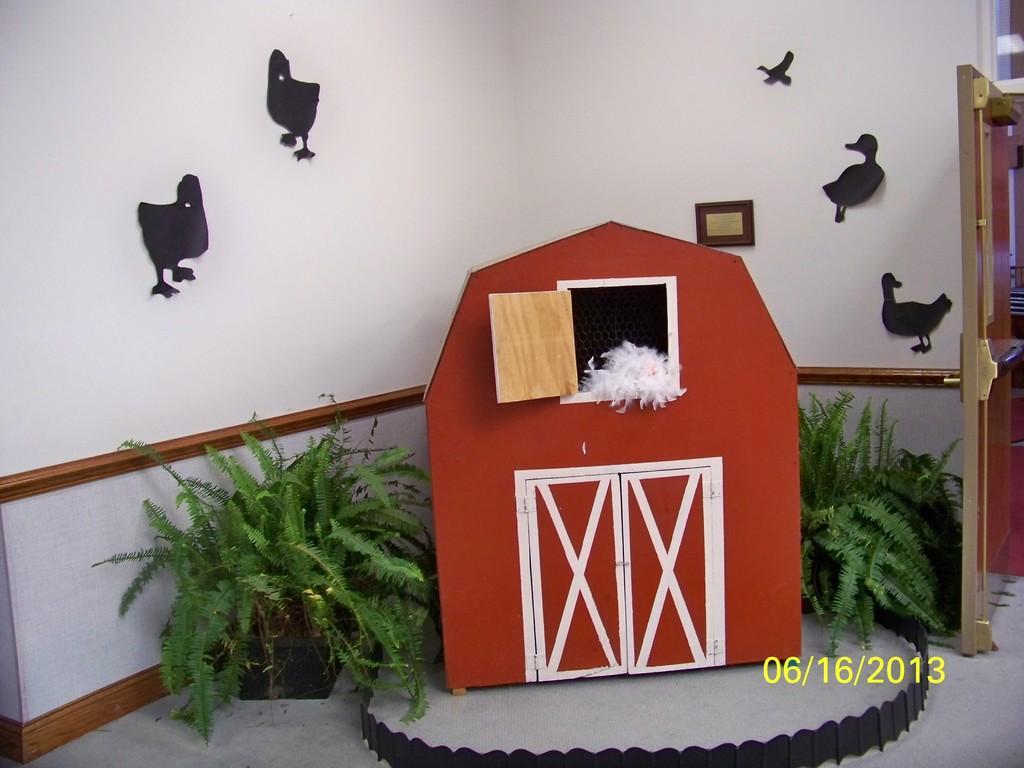Could you give a brief overview of what you see in this image? In this picture I can see plants in the pots and I can see a door and few pictures on the wall and it looks like a wooden box and I can see date at the bottom right corner of the picture. 